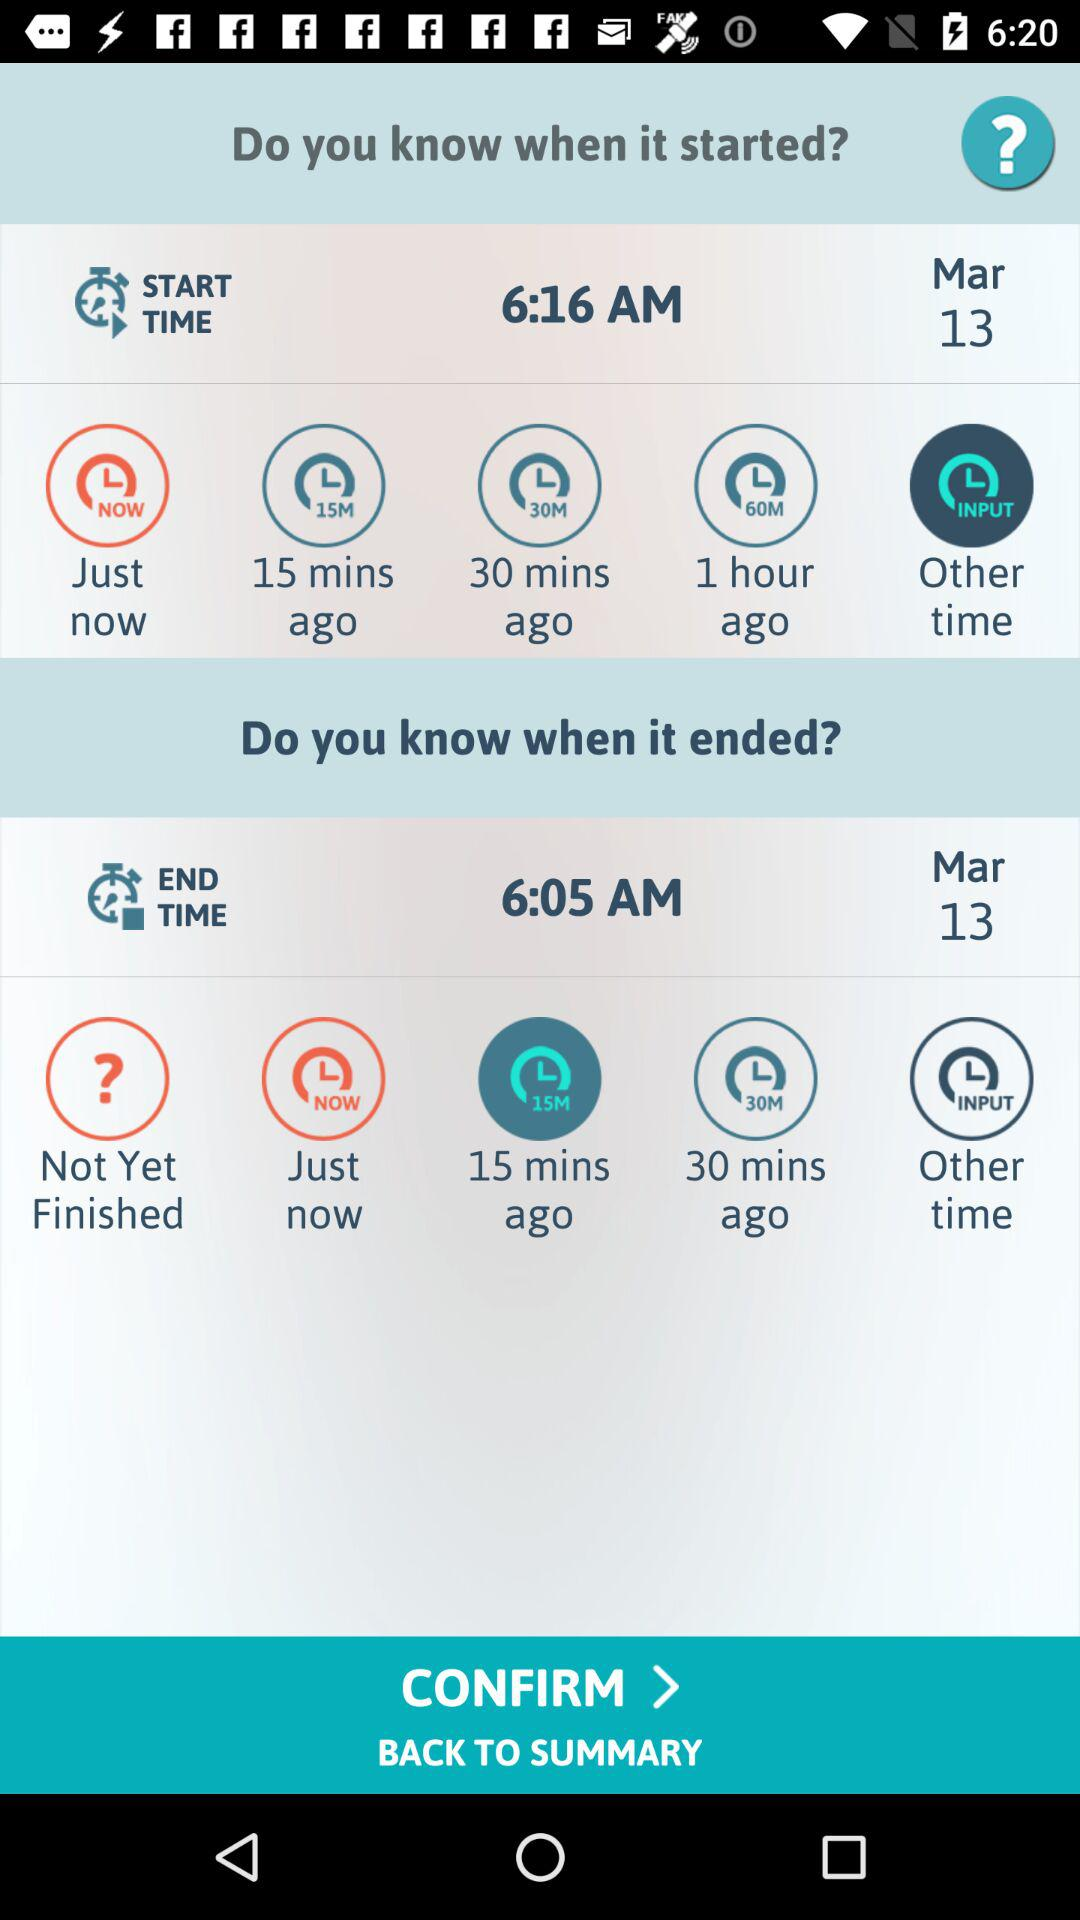How many minutes is the difference between the start and end times?
Answer the question using a single word or phrase. 11 